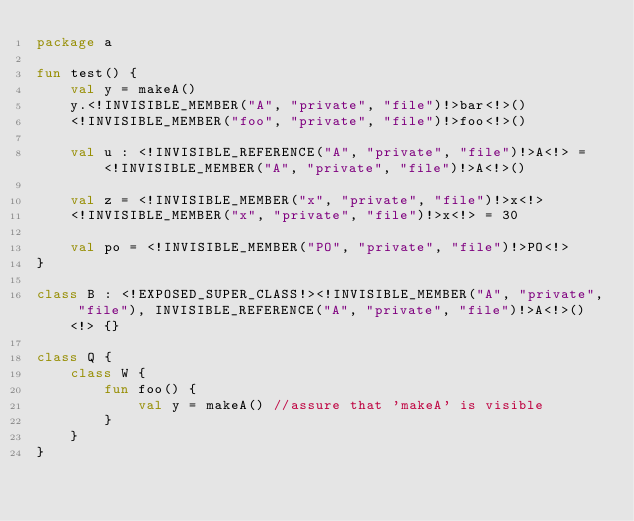Convert code to text. <code><loc_0><loc_0><loc_500><loc_500><_Kotlin_>package a

fun test() {
    val y = makeA()
    y.<!INVISIBLE_MEMBER("A", "private", "file")!>bar<!>()
    <!INVISIBLE_MEMBER("foo", "private", "file")!>foo<!>()

    val u : <!INVISIBLE_REFERENCE("A", "private", "file")!>A<!> = <!INVISIBLE_MEMBER("A", "private", "file")!>A<!>()

    val z = <!INVISIBLE_MEMBER("x", "private", "file")!>x<!>
    <!INVISIBLE_MEMBER("x", "private", "file")!>x<!> = 30

    val po = <!INVISIBLE_MEMBER("PO", "private", "file")!>PO<!>
}

class B : <!EXPOSED_SUPER_CLASS!><!INVISIBLE_MEMBER("A", "private", "file"), INVISIBLE_REFERENCE("A", "private", "file")!>A<!>()<!> {}

class Q {
    class W {
        fun foo() {
            val y = makeA() //assure that 'makeA' is visible
        }
    }
}
</code> 